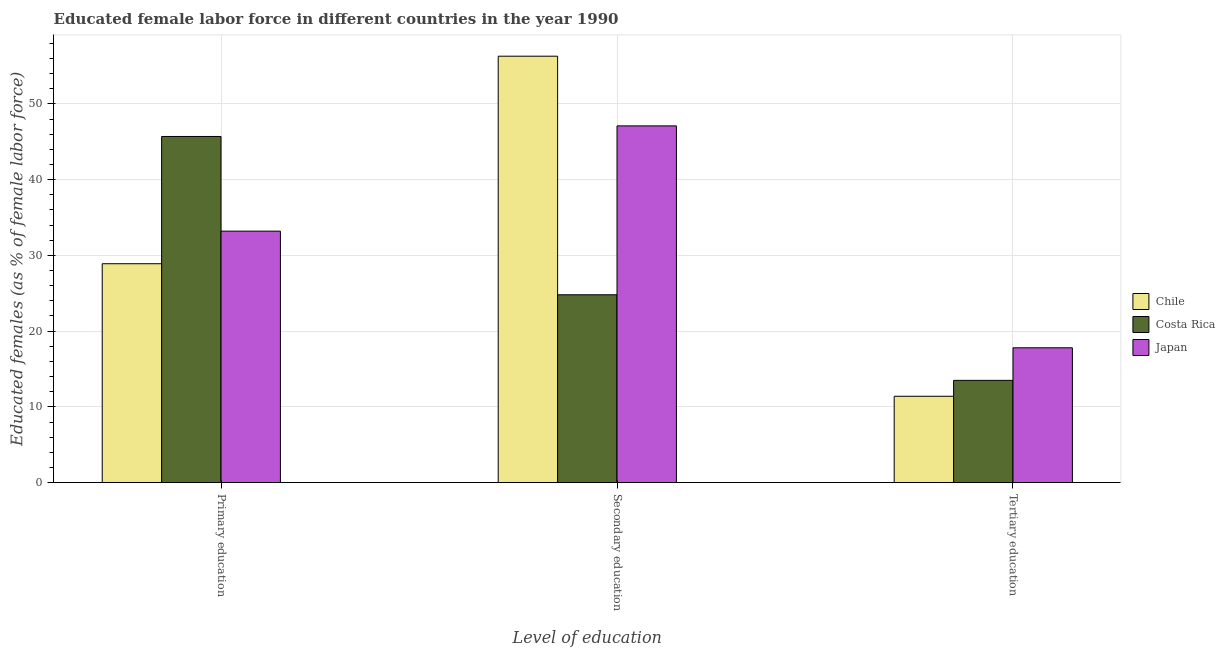How many different coloured bars are there?
Give a very brief answer. 3. Are the number of bars per tick equal to the number of legend labels?
Your answer should be very brief. Yes. Are the number of bars on each tick of the X-axis equal?
Ensure brevity in your answer.  Yes. How many bars are there on the 3rd tick from the left?
Your response must be concise. 3. How many bars are there on the 3rd tick from the right?
Offer a very short reply. 3. What is the label of the 2nd group of bars from the left?
Your answer should be compact. Secondary education. What is the percentage of female labor force who received primary education in Costa Rica?
Your answer should be compact. 45.7. Across all countries, what is the maximum percentage of female labor force who received secondary education?
Offer a very short reply. 56.3. Across all countries, what is the minimum percentage of female labor force who received secondary education?
Ensure brevity in your answer.  24.8. In which country was the percentage of female labor force who received primary education minimum?
Keep it short and to the point. Chile. What is the total percentage of female labor force who received tertiary education in the graph?
Offer a very short reply. 42.7. What is the difference between the percentage of female labor force who received secondary education in Japan and that in Chile?
Give a very brief answer. -9.2. What is the difference between the percentage of female labor force who received tertiary education in Chile and the percentage of female labor force who received secondary education in Japan?
Keep it short and to the point. -35.7. What is the average percentage of female labor force who received secondary education per country?
Your response must be concise. 42.73. What is the difference between the percentage of female labor force who received secondary education and percentage of female labor force who received primary education in Costa Rica?
Offer a terse response. -20.9. What is the ratio of the percentage of female labor force who received primary education in Costa Rica to that in Japan?
Provide a short and direct response. 1.38. What is the difference between the highest and the second highest percentage of female labor force who received primary education?
Provide a short and direct response. 12.5. What is the difference between the highest and the lowest percentage of female labor force who received primary education?
Offer a terse response. 16.8. What does the 2nd bar from the right in Primary education represents?
Your response must be concise. Costa Rica. How many bars are there?
Provide a short and direct response. 9. How many countries are there in the graph?
Keep it short and to the point. 3. Are the values on the major ticks of Y-axis written in scientific E-notation?
Your response must be concise. No. Does the graph contain grids?
Offer a very short reply. Yes. Where does the legend appear in the graph?
Offer a very short reply. Center right. How are the legend labels stacked?
Offer a very short reply. Vertical. What is the title of the graph?
Offer a very short reply. Educated female labor force in different countries in the year 1990. What is the label or title of the X-axis?
Provide a short and direct response. Level of education. What is the label or title of the Y-axis?
Your answer should be compact. Educated females (as % of female labor force). What is the Educated females (as % of female labor force) of Chile in Primary education?
Your response must be concise. 28.9. What is the Educated females (as % of female labor force) of Costa Rica in Primary education?
Your answer should be very brief. 45.7. What is the Educated females (as % of female labor force) in Japan in Primary education?
Offer a very short reply. 33.2. What is the Educated females (as % of female labor force) of Chile in Secondary education?
Give a very brief answer. 56.3. What is the Educated females (as % of female labor force) of Costa Rica in Secondary education?
Your answer should be compact. 24.8. What is the Educated females (as % of female labor force) of Japan in Secondary education?
Make the answer very short. 47.1. What is the Educated females (as % of female labor force) in Chile in Tertiary education?
Provide a short and direct response. 11.4. What is the Educated females (as % of female labor force) in Japan in Tertiary education?
Your answer should be very brief. 17.8. Across all Level of education, what is the maximum Educated females (as % of female labor force) in Chile?
Ensure brevity in your answer.  56.3. Across all Level of education, what is the maximum Educated females (as % of female labor force) of Costa Rica?
Give a very brief answer. 45.7. Across all Level of education, what is the maximum Educated females (as % of female labor force) in Japan?
Offer a terse response. 47.1. Across all Level of education, what is the minimum Educated females (as % of female labor force) in Chile?
Your response must be concise. 11.4. Across all Level of education, what is the minimum Educated females (as % of female labor force) of Japan?
Your response must be concise. 17.8. What is the total Educated females (as % of female labor force) in Chile in the graph?
Give a very brief answer. 96.6. What is the total Educated females (as % of female labor force) in Japan in the graph?
Your answer should be compact. 98.1. What is the difference between the Educated females (as % of female labor force) in Chile in Primary education and that in Secondary education?
Your answer should be compact. -27.4. What is the difference between the Educated females (as % of female labor force) in Costa Rica in Primary education and that in Secondary education?
Provide a short and direct response. 20.9. What is the difference between the Educated females (as % of female labor force) of Chile in Primary education and that in Tertiary education?
Make the answer very short. 17.5. What is the difference between the Educated females (as % of female labor force) in Costa Rica in Primary education and that in Tertiary education?
Your response must be concise. 32.2. What is the difference between the Educated females (as % of female labor force) of Chile in Secondary education and that in Tertiary education?
Give a very brief answer. 44.9. What is the difference between the Educated females (as % of female labor force) of Costa Rica in Secondary education and that in Tertiary education?
Offer a very short reply. 11.3. What is the difference between the Educated females (as % of female labor force) of Japan in Secondary education and that in Tertiary education?
Give a very brief answer. 29.3. What is the difference between the Educated females (as % of female labor force) in Chile in Primary education and the Educated females (as % of female labor force) in Japan in Secondary education?
Provide a succinct answer. -18.2. What is the difference between the Educated females (as % of female labor force) of Chile in Primary education and the Educated females (as % of female labor force) of Costa Rica in Tertiary education?
Provide a short and direct response. 15.4. What is the difference between the Educated females (as % of female labor force) in Chile in Primary education and the Educated females (as % of female labor force) in Japan in Tertiary education?
Make the answer very short. 11.1. What is the difference between the Educated females (as % of female labor force) in Costa Rica in Primary education and the Educated females (as % of female labor force) in Japan in Tertiary education?
Provide a short and direct response. 27.9. What is the difference between the Educated females (as % of female labor force) in Chile in Secondary education and the Educated females (as % of female labor force) in Costa Rica in Tertiary education?
Offer a very short reply. 42.8. What is the difference between the Educated females (as % of female labor force) in Chile in Secondary education and the Educated females (as % of female labor force) in Japan in Tertiary education?
Your response must be concise. 38.5. What is the difference between the Educated females (as % of female labor force) in Costa Rica in Secondary education and the Educated females (as % of female labor force) in Japan in Tertiary education?
Keep it short and to the point. 7. What is the average Educated females (as % of female labor force) in Chile per Level of education?
Provide a succinct answer. 32.2. What is the average Educated females (as % of female labor force) of Japan per Level of education?
Give a very brief answer. 32.7. What is the difference between the Educated females (as % of female labor force) in Chile and Educated females (as % of female labor force) in Costa Rica in Primary education?
Your response must be concise. -16.8. What is the difference between the Educated females (as % of female labor force) in Costa Rica and Educated females (as % of female labor force) in Japan in Primary education?
Make the answer very short. 12.5. What is the difference between the Educated females (as % of female labor force) in Chile and Educated females (as % of female labor force) in Costa Rica in Secondary education?
Offer a terse response. 31.5. What is the difference between the Educated females (as % of female labor force) in Costa Rica and Educated females (as % of female labor force) in Japan in Secondary education?
Provide a succinct answer. -22.3. What is the ratio of the Educated females (as % of female labor force) in Chile in Primary education to that in Secondary education?
Provide a short and direct response. 0.51. What is the ratio of the Educated females (as % of female labor force) in Costa Rica in Primary education to that in Secondary education?
Your answer should be compact. 1.84. What is the ratio of the Educated females (as % of female labor force) in Japan in Primary education to that in Secondary education?
Offer a very short reply. 0.7. What is the ratio of the Educated females (as % of female labor force) in Chile in Primary education to that in Tertiary education?
Make the answer very short. 2.54. What is the ratio of the Educated females (as % of female labor force) of Costa Rica in Primary education to that in Tertiary education?
Make the answer very short. 3.39. What is the ratio of the Educated females (as % of female labor force) in Japan in Primary education to that in Tertiary education?
Provide a short and direct response. 1.87. What is the ratio of the Educated females (as % of female labor force) of Chile in Secondary education to that in Tertiary education?
Make the answer very short. 4.94. What is the ratio of the Educated females (as % of female labor force) of Costa Rica in Secondary education to that in Tertiary education?
Offer a very short reply. 1.84. What is the ratio of the Educated females (as % of female labor force) of Japan in Secondary education to that in Tertiary education?
Offer a terse response. 2.65. What is the difference between the highest and the second highest Educated females (as % of female labor force) in Chile?
Provide a succinct answer. 27.4. What is the difference between the highest and the second highest Educated females (as % of female labor force) in Costa Rica?
Ensure brevity in your answer.  20.9. What is the difference between the highest and the second highest Educated females (as % of female labor force) in Japan?
Your answer should be compact. 13.9. What is the difference between the highest and the lowest Educated females (as % of female labor force) of Chile?
Your answer should be very brief. 44.9. What is the difference between the highest and the lowest Educated females (as % of female labor force) in Costa Rica?
Provide a short and direct response. 32.2. What is the difference between the highest and the lowest Educated females (as % of female labor force) of Japan?
Ensure brevity in your answer.  29.3. 